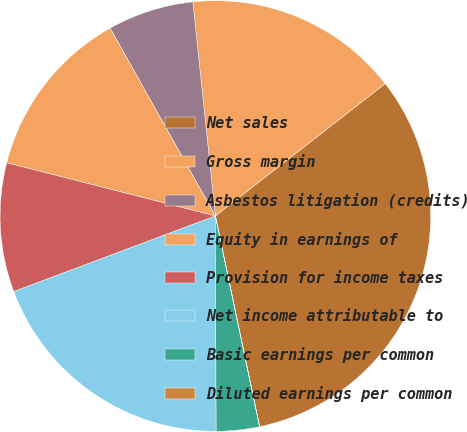<chart> <loc_0><loc_0><loc_500><loc_500><pie_chart><fcel>Net sales<fcel>Gross margin<fcel>Asbestos litigation (credits)<fcel>Equity in earnings of<fcel>Provision for income taxes<fcel>Net income attributable to<fcel>Basic earnings per common<fcel>Diluted earnings per common<nl><fcel>32.24%<fcel>16.13%<fcel>6.46%<fcel>12.9%<fcel>9.68%<fcel>19.35%<fcel>3.23%<fcel>0.01%<nl></chart> 